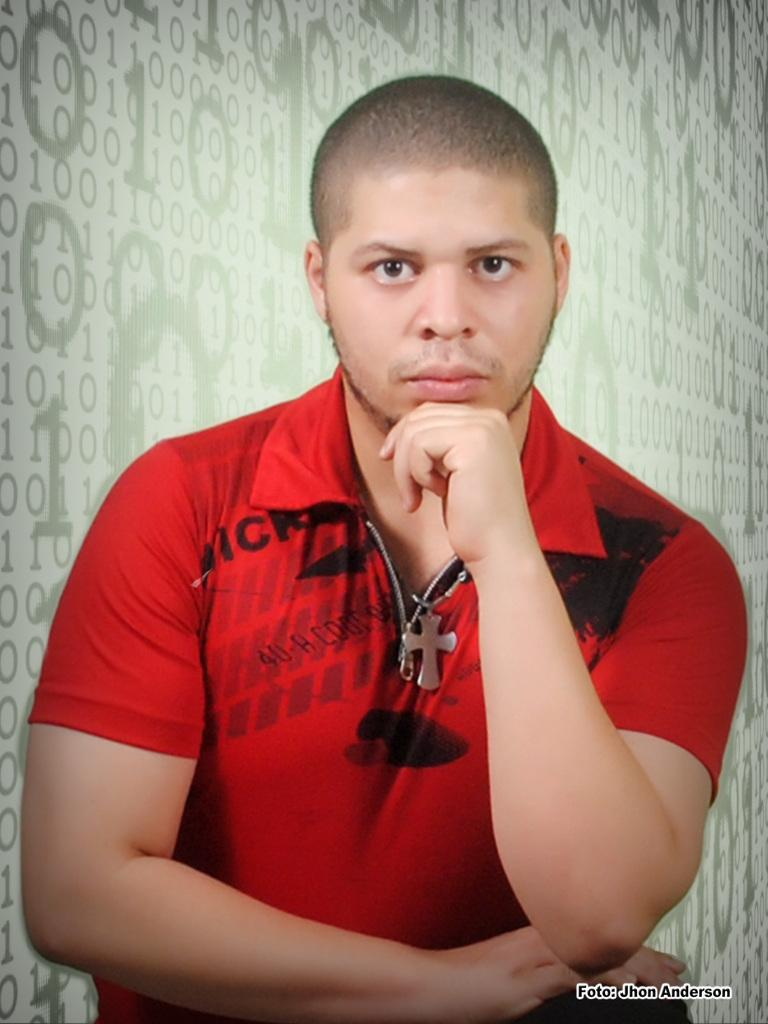What is the main subject of the image? There is a man in the image. What is the man wearing in the image? The man is wearing a red t-shirt. What type of pleasure can be seen in the man's facial expression in the image? There is no indication of the man's facial expression in the image, so it cannot be determined if he is experiencing pleasure or any other emotion. 